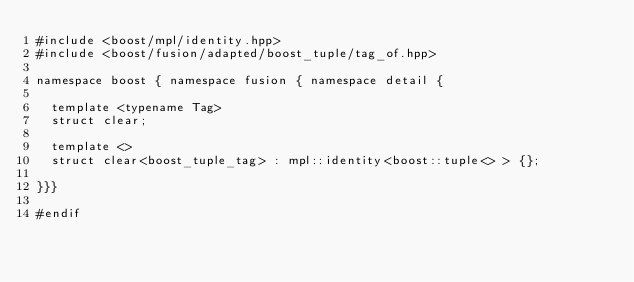Convert code to text. <code><loc_0><loc_0><loc_500><loc_500><_C++_>#include <boost/mpl/identity.hpp>
#include <boost/fusion/adapted/boost_tuple/tag_of.hpp>

namespace boost { namespace fusion { namespace detail {

  template <typename Tag>
  struct clear;

  template <>
  struct clear<boost_tuple_tag> : mpl::identity<boost::tuple<> > {};

}}}

#endif
</code> 